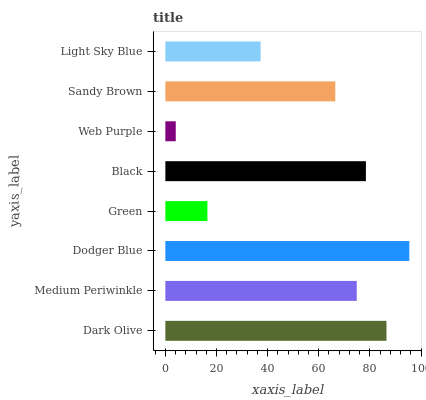Is Web Purple the minimum?
Answer yes or no. Yes. Is Dodger Blue the maximum?
Answer yes or no. Yes. Is Medium Periwinkle the minimum?
Answer yes or no. No. Is Medium Periwinkle the maximum?
Answer yes or no. No. Is Dark Olive greater than Medium Periwinkle?
Answer yes or no. Yes. Is Medium Periwinkle less than Dark Olive?
Answer yes or no. Yes. Is Medium Periwinkle greater than Dark Olive?
Answer yes or no. No. Is Dark Olive less than Medium Periwinkle?
Answer yes or no. No. Is Medium Periwinkle the high median?
Answer yes or no. Yes. Is Sandy Brown the low median?
Answer yes or no. Yes. Is Dark Olive the high median?
Answer yes or no. No. Is Black the low median?
Answer yes or no. No. 